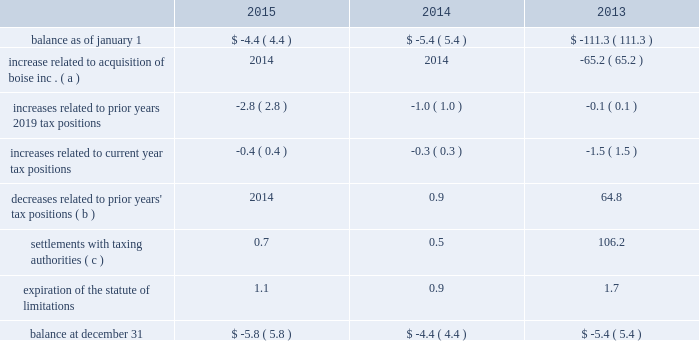Cash payments for federal , state , and foreign income taxes were $ 238.3 million , $ 189.5 million , and $ 90.7 million for the years ended december 31 , 2015 , 2014 , and 2013 , respectively .
The table summarizes the changes related to pca 2019s gross unrecognized tax benefits excluding interest and penalties ( dollars in millions ) : .
( a ) in 2013 , pca acquired $ 65.2 million of gross unrecognized tax benefits from boise inc .
That related primarily to the taxability of the alternative energy tax credits .
( b ) the 2013 amount includes a $ 64.3 million gross decrease related to the taxability of the alternative energy tax credits claimed in 2009 excise tax returns by boise inc .
For further discussion regarding these credits , see note 7 , alternative energy tax credits .
( c ) the 2013 amount includes a $ 104.7 million gross decrease related to the conclusion of the internal revenue service audit of pca 2019s alternative energy tax credits .
For further discussion regarding these credits , see note 7 , alternative energy tax credits .
At december 31 , 2015 , pca had recorded a $ 5.8 million gross reserve for unrecognized tax benefits , excluding interest and penalties .
Of the total , $ 4.2 million ( net of the federal benefit for state taxes ) would impact the effective tax rate if recognized .
Pca recognizes interest accrued related to unrecognized tax benefits and penalties as income tax expense .
At december 31 , 2015 and 2014 , we had an insignificant amount of interest and penalties recorded for unrecognized tax benefits included in the table above .
Pca does not expect the unrecognized tax benefits to change significantly over the next 12 months .
Pca is subject to taxation in the united states and various state and foreign jurisdictions .
A federal examination of the tax years 2010 2014 2012 was concluded in february 2015 .
A federal examination of the 2013 tax year began in october 2015 .
The tax years 2014 2014 2015 remain open to federal examination .
The tax years 2011 2014 2015 remain open to state examinations .
Some foreign tax jurisdictions are open to examination for the 2008 tax year forward .
Through the boise acquisition , pca recorded net operating losses and credit carryforwards from 2008 through 2011 and 2013 that are subject to examinations and adjustments for at least three years following the year in which utilized .
Alternative energy tax credits the company generates black liquor as a by-product of its pulp manufacturing process , which entitled it to certain federal income tax credits .
When black liquor is mixed with diesel , it is considered an alternative fuel that was eligible for a $ 0.50 per gallon refundable alternative energy tax credit for gallons produced before december 31 , 2009 .
Black liquor was also eligible for a $ 1.01 per gallon taxable cellulosic biofuel producer credit for gallons of black liquor produced and used in 2009 .
In 2013 , we reversed $ 166.0 million of a reserve for unrecognized tax benefits for alternative energy tax credits as a benefit to income taxes .
Approximately $ 103.9 million ( $ 102.0 million of tax , net of the federal benefit for state taxes , plus $ 1.9 million of accrued interest ) of the reversal is due to the completion of the irs .
Of the decreases related to prior years' tax positions , what percent of the 2013 amount is the gross decrease related to the taxability of the alternative energy tax credits claimed in 2009 excise tax returns by boise inc? 
Computations: (64.3 / 64.8)
Answer: 0.99228. 